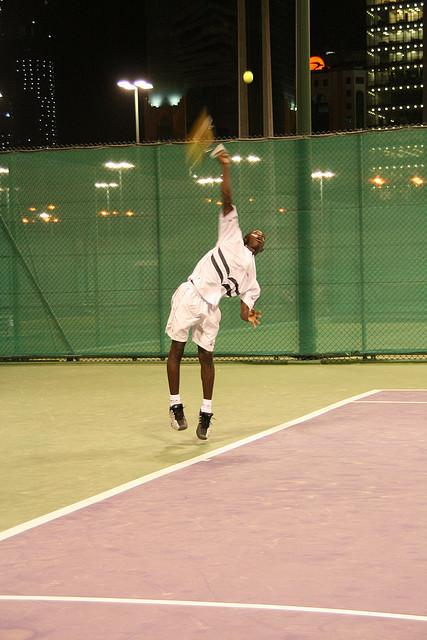What is the man swinging? tennis racket 